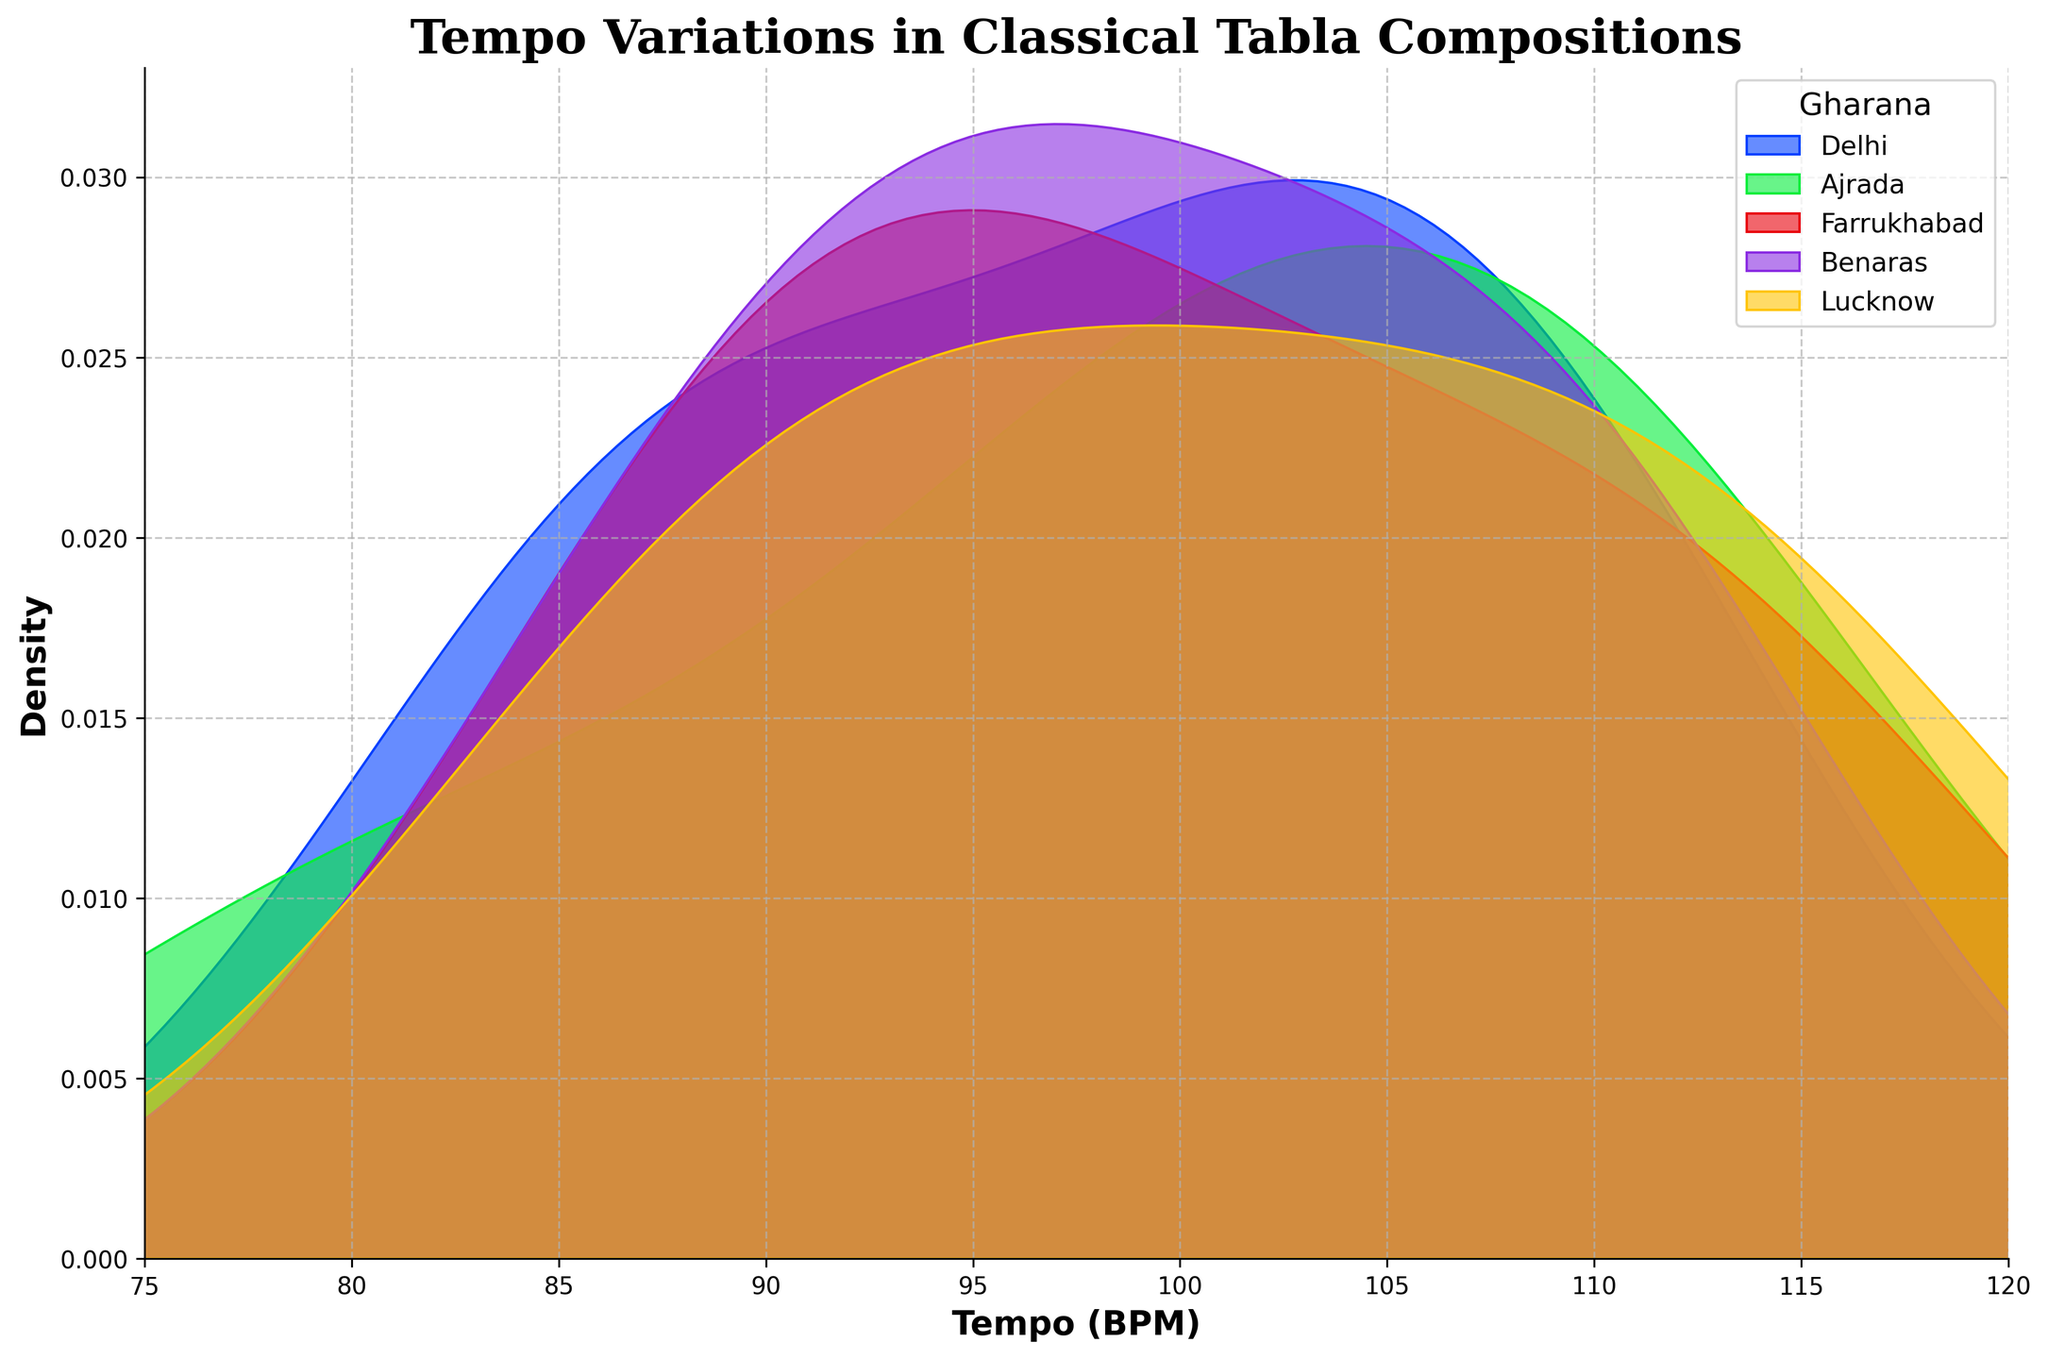What is the title of the plot? The title is usually displayed at the top of the plot and often summarizes the main point or focus. In this case, it should align with the data being visualized.
Answer: Tempo Variations in Classical Tabla Compositions Which gharana shows the widest range of tempo values? The width of the dense area give visual clues about range. The wider it spreads out, the larger the range.
Answer: Lucknow What is the tempo range displayed on the x-axis? This information is visible by looking at the annotation on the x-axis that indicates the start and end values.
Answer: 75 BPM to 120 BPM Which gharana has the highest peak in the density plot? The peak height indicates which gharana's compositions are most frequent at a certain tempo.
Answer: Farrukhabad Do any gharanas overlap significantly in their tempo distributions? Overlapping areas in density plots show similar tempo ranges, indicating that these gharanas share close tempo values for their compositions.
Answer: Yes Which gharana has the lowest tempo value shown in the plot? The minimum tempo value can be observed on the far left of the x-axis where the density plot starts.
Answer: Ajrada Which gharanas have peak densities close to 100 BPM? The peaks near the 100 BPM mark indicate the gharanas whose compositions frequently have tempos around that value. Observing the peaks near 100 BPM can answer this.
Answer: Delhi and Ajrada Which gharana has the most compositions with very high tempos (above 110 BPM)? This can be inferred by seeing which density curves have significant areas beyond 110 BPM.
Answer: Lucknow What's the mode tempo for the Farrukhabad gharana? The mode tempo is the tempo with the highest density. For Farrukhabad, it's where its density plot peaks.
Answer: Around 100 BPM Which gharanas have similar tempo distributions in terms of peak shape and spread? By comparing the heights, spreads, and positions of the density peaks, one can infer which gharanas have similar tempo distributions.
Answer: Benaras and Ajrada 